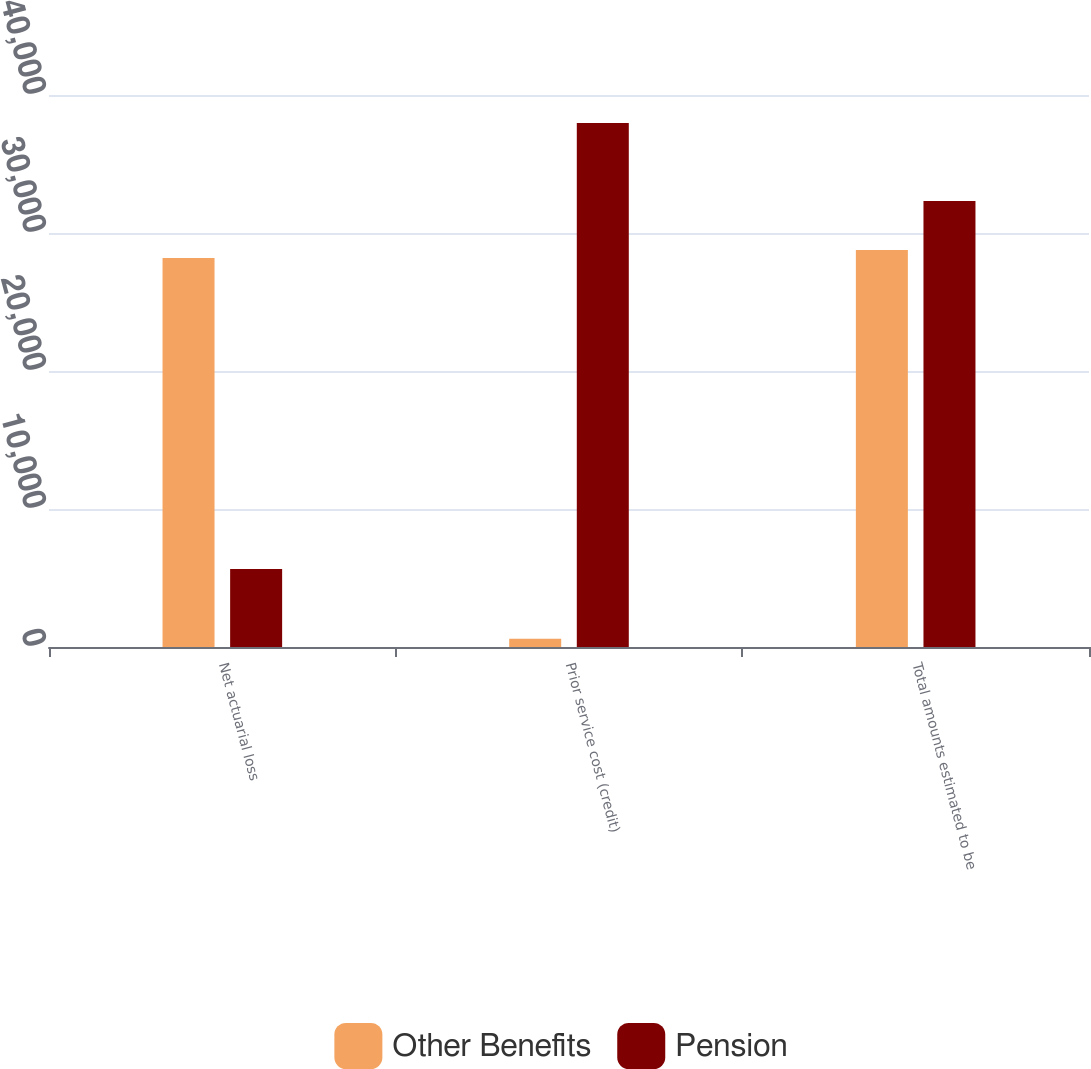<chart> <loc_0><loc_0><loc_500><loc_500><stacked_bar_chart><ecel><fcel>Net actuarial loss<fcel>Prior service cost (credit)<fcel>Total amounts estimated to be<nl><fcel>Other Benefits<fcel>28180<fcel>595<fcel>28775<nl><fcel>Pension<fcel>5651<fcel>37968<fcel>32317<nl></chart> 